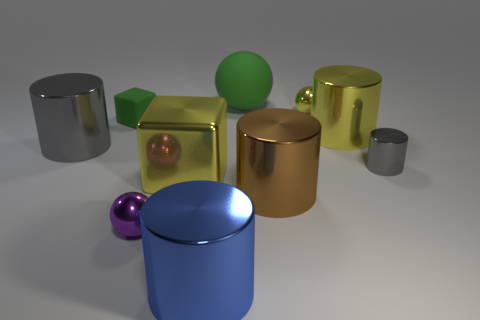What shape is the big object that is the same color as the big block?
Give a very brief answer. Cylinder. There is a matte thing that is behind the small shiny ball behind the gray cylinder left of the large rubber thing; what is its shape?
Offer a terse response. Sphere. How many other objects are there of the same shape as the small yellow thing?
Offer a very short reply. 2. What number of matte things are either big yellow objects or purple balls?
Provide a short and direct response. 0. There is a tiny ball that is to the left of the brown cylinder that is in front of the large gray metallic cylinder; what is its material?
Offer a very short reply. Metal. Is the number of tiny gray objects to the right of the small gray cylinder greater than the number of balls?
Your answer should be very brief. No. Are there any small things made of the same material as the large green ball?
Ensure brevity in your answer.  Yes. Is the shape of the green object that is left of the blue thing the same as  the big brown metal object?
Make the answer very short. No. There is a tiny ball that is in front of the large cylinder left of the purple metallic object; what number of big blue shiny things are in front of it?
Keep it short and to the point. 1. Are there fewer objects right of the large brown thing than large gray cylinders behind the yellow metal ball?
Provide a succinct answer. No. 